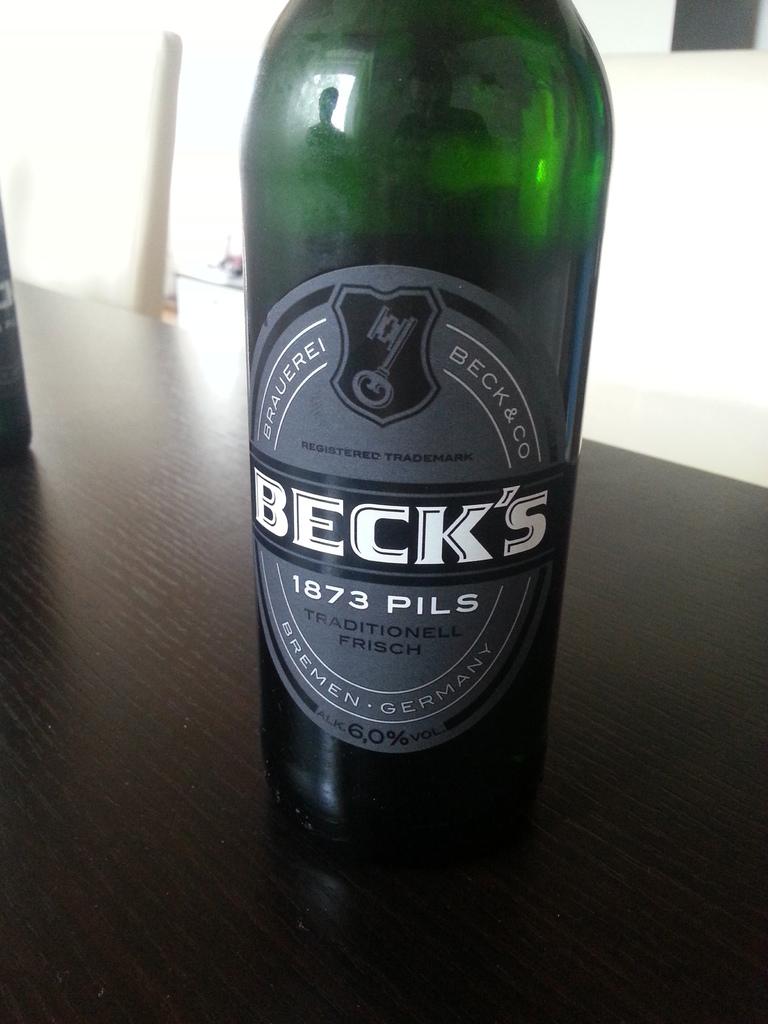What's the percentage of alcohol in this drink?
Make the answer very short. 6.0%. Look the picture is beer or liquor?
Provide a short and direct response. Beer. 